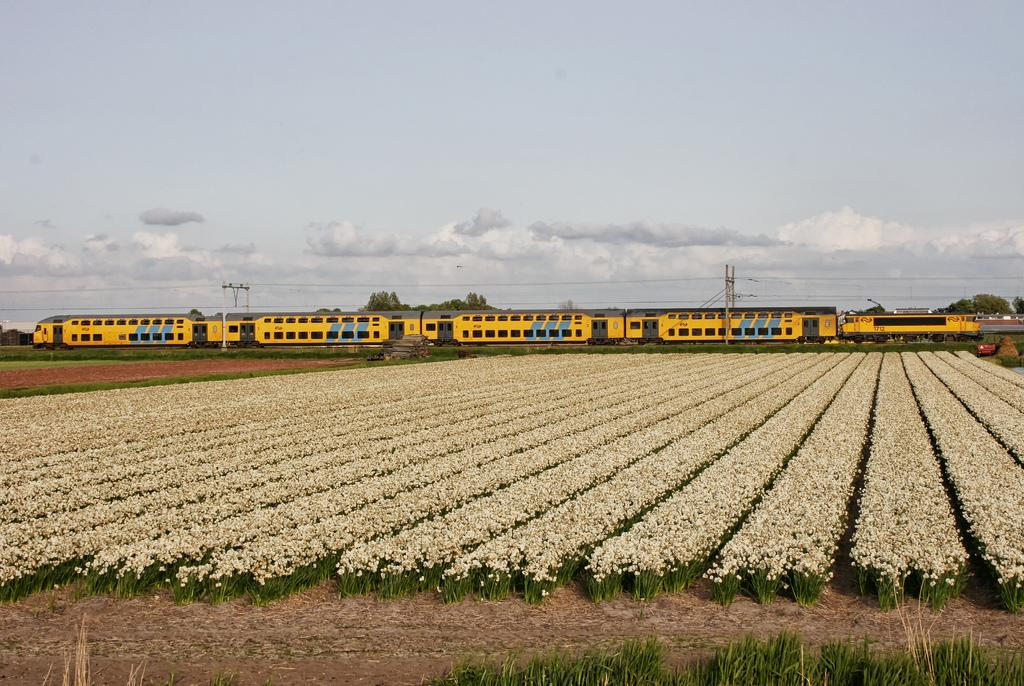What is the main subject of the image? There is a train in the center of the image. What is the train's position in relation to its surroundings? The train is on a track. What type of natural elements can be seen in the image? There are plants visible in the image. What can be seen in the background of the image? The sky and poles are visible in the background of the image. What brand of toothpaste is being advertised on the train in the image? There is no toothpaste or advertisement present on the train in the image. 